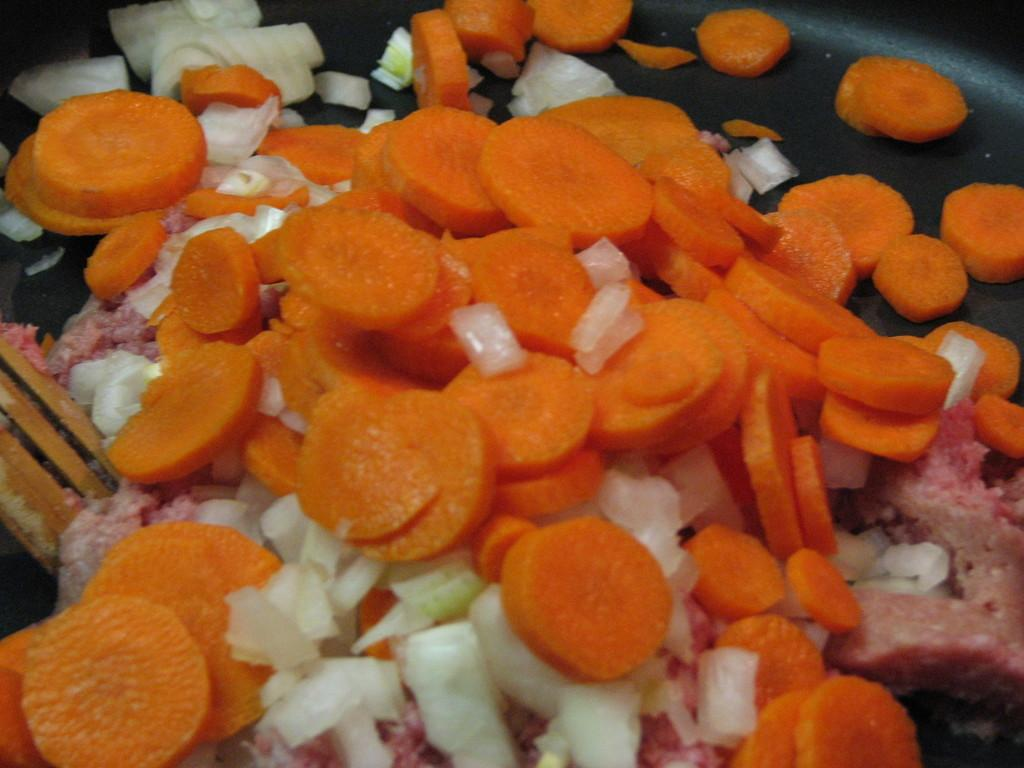What is in the pan that is visible in the image? There are carrots, onions, and meat in the pan. What utensil is present in the image? There is a spatula in the image. What might be used to stir or flip the ingredients in the pan? The spatula can be used to stir or flip the ingredients in the pan. What type of debt can be seen in the image? There is no debt visible in the image; it features a pan with carrots, onions, and meat. Can you play the guitar in the image? There is no guitar present in the image. 